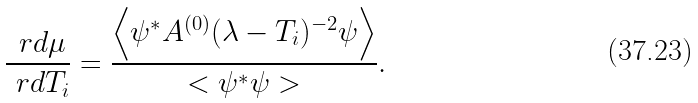Convert formula to latex. <formula><loc_0><loc_0><loc_500><loc_500>\frac { \ r d \mu } { \ r d T _ { i } } = \frac { \Big < \psi ^ { * } A ^ { ( 0 ) } ( \lambda - T _ { i } ) ^ { - 2 } \psi \Big > } { < \psi ^ { * } \psi > } .</formula> 